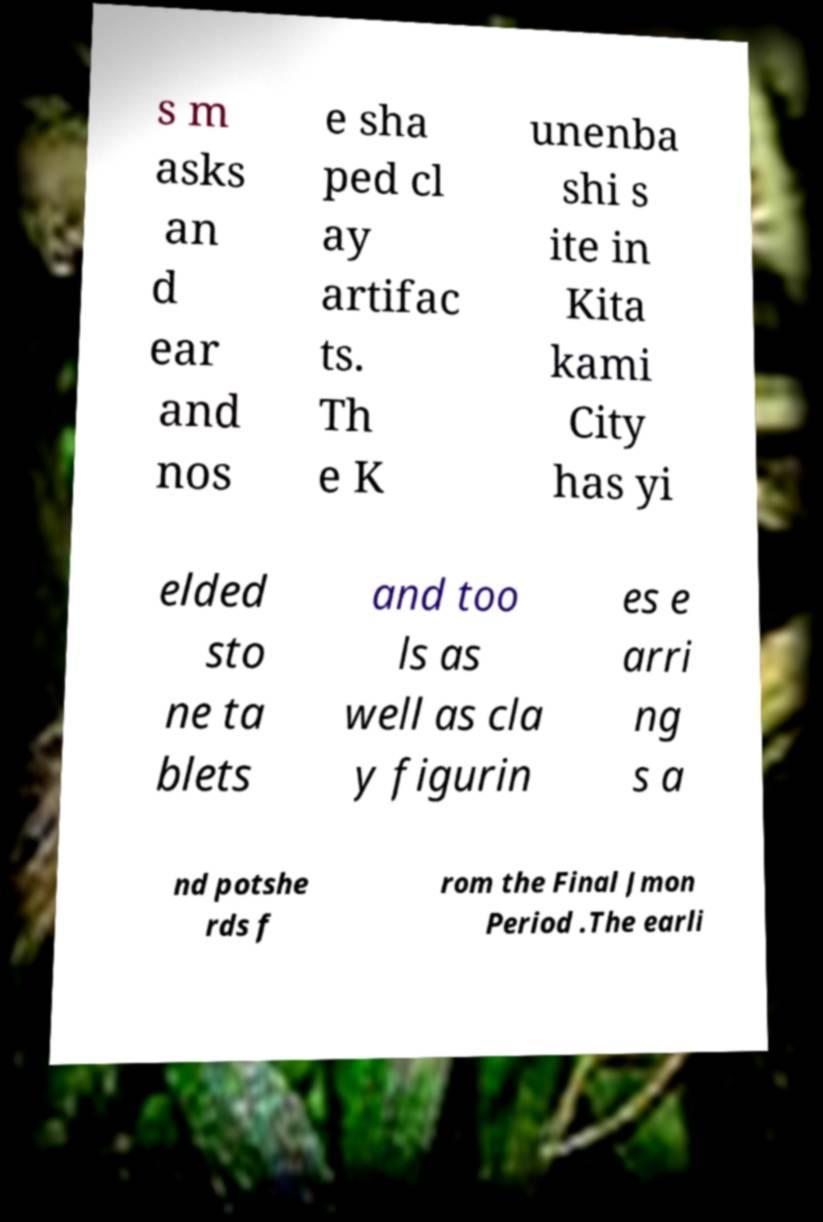I need the written content from this picture converted into text. Can you do that? s m asks an d ear and nos e sha ped cl ay artifac ts. Th e K unenba shi s ite in Kita kami City has yi elded sto ne ta blets and too ls as well as cla y figurin es e arri ng s a nd potshe rds f rom the Final Jmon Period .The earli 